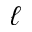<formula> <loc_0><loc_0><loc_500><loc_500>\ell</formula> 